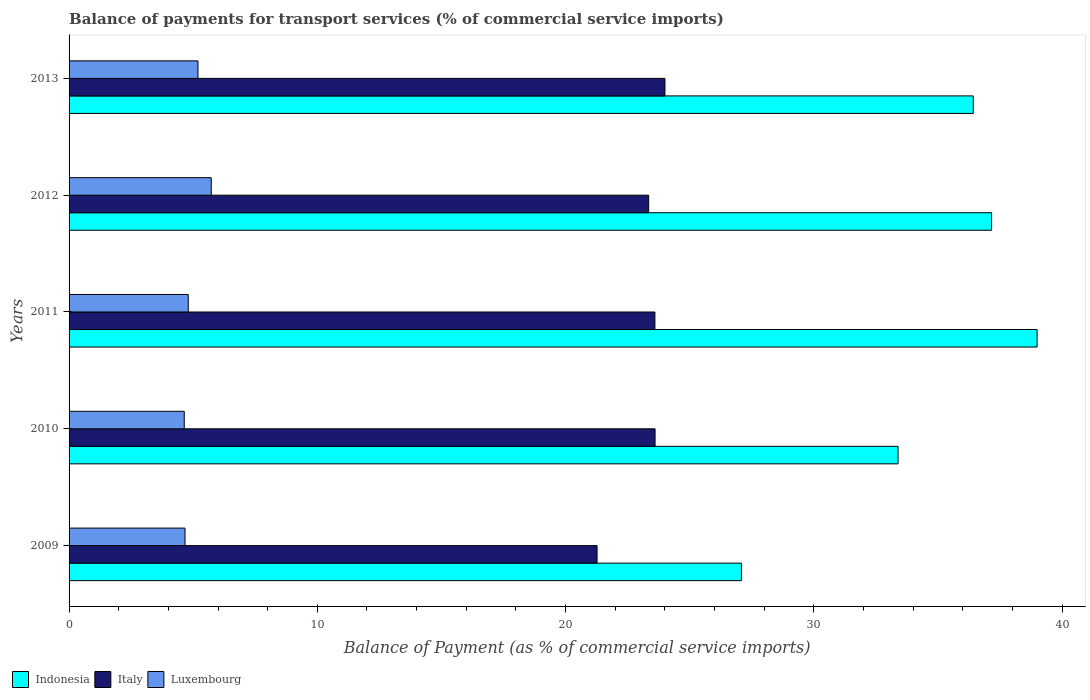How many different coloured bars are there?
Make the answer very short. 3. How many groups of bars are there?
Your answer should be very brief. 5. How many bars are there on the 2nd tick from the top?
Provide a succinct answer. 3. In how many cases, is the number of bars for a given year not equal to the number of legend labels?
Give a very brief answer. 0. What is the balance of payments for transport services in Indonesia in 2012?
Your response must be concise. 37.16. Across all years, what is the maximum balance of payments for transport services in Italy?
Provide a succinct answer. 24. Across all years, what is the minimum balance of payments for transport services in Indonesia?
Offer a terse response. 27.08. In which year was the balance of payments for transport services in Luxembourg maximum?
Give a very brief answer. 2012. In which year was the balance of payments for transport services in Indonesia minimum?
Offer a very short reply. 2009. What is the total balance of payments for transport services in Italy in the graph?
Keep it short and to the point. 115.82. What is the difference between the balance of payments for transport services in Indonesia in 2011 and that in 2012?
Provide a succinct answer. 1.83. What is the difference between the balance of payments for transport services in Indonesia in 2009 and the balance of payments for transport services in Luxembourg in 2013?
Offer a very short reply. 21.89. What is the average balance of payments for transport services in Indonesia per year?
Provide a short and direct response. 34.61. In the year 2011, what is the difference between the balance of payments for transport services in Indonesia and balance of payments for transport services in Luxembourg?
Give a very brief answer. 34.19. What is the ratio of the balance of payments for transport services in Luxembourg in 2010 to that in 2013?
Provide a short and direct response. 0.89. Is the balance of payments for transport services in Indonesia in 2010 less than that in 2013?
Provide a short and direct response. Yes. What is the difference between the highest and the second highest balance of payments for transport services in Luxembourg?
Offer a very short reply. 0.53. What is the difference between the highest and the lowest balance of payments for transport services in Italy?
Make the answer very short. 2.73. Is the sum of the balance of payments for transport services in Indonesia in 2009 and 2012 greater than the maximum balance of payments for transport services in Italy across all years?
Ensure brevity in your answer.  Yes. What does the 3rd bar from the bottom in 2011 represents?
Offer a very short reply. Luxembourg. Is it the case that in every year, the sum of the balance of payments for transport services in Luxembourg and balance of payments for transport services in Italy is greater than the balance of payments for transport services in Indonesia?
Provide a succinct answer. No. Are all the bars in the graph horizontal?
Ensure brevity in your answer.  Yes. Are the values on the major ticks of X-axis written in scientific E-notation?
Offer a terse response. No. Does the graph contain grids?
Ensure brevity in your answer.  No. How many legend labels are there?
Your answer should be compact. 3. What is the title of the graph?
Keep it short and to the point. Balance of payments for transport services (% of commercial service imports). Does "Middle East & North Africa (developing only)" appear as one of the legend labels in the graph?
Ensure brevity in your answer.  No. What is the label or title of the X-axis?
Give a very brief answer. Balance of Payment (as % of commercial service imports). What is the label or title of the Y-axis?
Make the answer very short. Years. What is the Balance of Payment (as % of commercial service imports) in Indonesia in 2009?
Ensure brevity in your answer.  27.08. What is the Balance of Payment (as % of commercial service imports) of Italy in 2009?
Keep it short and to the point. 21.27. What is the Balance of Payment (as % of commercial service imports) of Luxembourg in 2009?
Provide a succinct answer. 4.67. What is the Balance of Payment (as % of commercial service imports) in Indonesia in 2010?
Keep it short and to the point. 33.39. What is the Balance of Payment (as % of commercial service imports) in Italy in 2010?
Make the answer very short. 23.61. What is the Balance of Payment (as % of commercial service imports) of Luxembourg in 2010?
Give a very brief answer. 4.64. What is the Balance of Payment (as % of commercial service imports) in Indonesia in 2011?
Provide a short and direct response. 38.99. What is the Balance of Payment (as % of commercial service imports) in Italy in 2011?
Provide a short and direct response. 23.6. What is the Balance of Payment (as % of commercial service imports) of Luxembourg in 2011?
Give a very brief answer. 4.8. What is the Balance of Payment (as % of commercial service imports) of Indonesia in 2012?
Provide a short and direct response. 37.16. What is the Balance of Payment (as % of commercial service imports) of Italy in 2012?
Provide a succinct answer. 23.35. What is the Balance of Payment (as % of commercial service imports) in Luxembourg in 2012?
Offer a terse response. 5.73. What is the Balance of Payment (as % of commercial service imports) of Indonesia in 2013?
Your answer should be very brief. 36.42. What is the Balance of Payment (as % of commercial service imports) of Italy in 2013?
Your response must be concise. 24. What is the Balance of Payment (as % of commercial service imports) of Luxembourg in 2013?
Your response must be concise. 5.19. Across all years, what is the maximum Balance of Payment (as % of commercial service imports) of Indonesia?
Offer a very short reply. 38.99. Across all years, what is the maximum Balance of Payment (as % of commercial service imports) of Italy?
Your answer should be very brief. 24. Across all years, what is the maximum Balance of Payment (as % of commercial service imports) of Luxembourg?
Your response must be concise. 5.73. Across all years, what is the minimum Balance of Payment (as % of commercial service imports) of Indonesia?
Your response must be concise. 27.08. Across all years, what is the minimum Balance of Payment (as % of commercial service imports) of Italy?
Provide a succinct answer. 21.27. Across all years, what is the minimum Balance of Payment (as % of commercial service imports) in Luxembourg?
Offer a terse response. 4.64. What is the total Balance of Payment (as % of commercial service imports) of Indonesia in the graph?
Make the answer very short. 173.06. What is the total Balance of Payment (as % of commercial service imports) of Italy in the graph?
Give a very brief answer. 115.82. What is the total Balance of Payment (as % of commercial service imports) in Luxembourg in the graph?
Make the answer very short. 25.03. What is the difference between the Balance of Payment (as % of commercial service imports) of Indonesia in 2009 and that in 2010?
Keep it short and to the point. -6.31. What is the difference between the Balance of Payment (as % of commercial service imports) in Italy in 2009 and that in 2010?
Ensure brevity in your answer.  -2.34. What is the difference between the Balance of Payment (as % of commercial service imports) in Luxembourg in 2009 and that in 2010?
Your response must be concise. 0.03. What is the difference between the Balance of Payment (as % of commercial service imports) in Indonesia in 2009 and that in 2011?
Your answer should be compact. -11.91. What is the difference between the Balance of Payment (as % of commercial service imports) of Italy in 2009 and that in 2011?
Provide a succinct answer. -2.33. What is the difference between the Balance of Payment (as % of commercial service imports) in Luxembourg in 2009 and that in 2011?
Make the answer very short. -0.13. What is the difference between the Balance of Payment (as % of commercial service imports) in Indonesia in 2009 and that in 2012?
Keep it short and to the point. -10.08. What is the difference between the Balance of Payment (as % of commercial service imports) of Italy in 2009 and that in 2012?
Ensure brevity in your answer.  -2.08. What is the difference between the Balance of Payment (as % of commercial service imports) in Luxembourg in 2009 and that in 2012?
Your answer should be compact. -1.06. What is the difference between the Balance of Payment (as % of commercial service imports) in Indonesia in 2009 and that in 2013?
Ensure brevity in your answer.  -9.34. What is the difference between the Balance of Payment (as % of commercial service imports) in Italy in 2009 and that in 2013?
Offer a terse response. -2.73. What is the difference between the Balance of Payment (as % of commercial service imports) in Luxembourg in 2009 and that in 2013?
Offer a very short reply. -0.52. What is the difference between the Balance of Payment (as % of commercial service imports) in Indonesia in 2010 and that in 2011?
Give a very brief answer. -5.6. What is the difference between the Balance of Payment (as % of commercial service imports) in Italy in 2010 and that in 2011?
Make the answer very short. 0.01. What is the difference between the Balance of Payment (as % of commercial service imports) in Luxembourg in 2010 and that in 2011?
Give a very brief answer. -0.16. What is the difference between the Balance of Payment (as % of commercial service imports) in Indonesia in 2010 and that in 2012?
Provide a succinct answer. -3.77. What is the difference between the Balance of Payment (as % of commercial service imports) of Italy in 2010 and that in 2012?
Provide a short and direct response. 0.26. What is the difference between the Balance of Payment (as % of commercial service imports) in Luxembourg in 2010 and that in 2012?
Give a very brief answer. -1.09. What is the difference between the Balance of Payment (as % of commercial service imports) in Indonesia in 2010 and that in 2013?
Provide a short and direct response. -3.03. What is the difference between the Balance of Payment (as % of commercial service imports) of Italy in 2010 and that in 2013?
Give a very brief answer. -0.4. What is the difference between the Balance of Payment (as % of commercial service imports) in Luxembourg in 2010 and that in 2013?
Provide a short and direct response. -0.55. What is the difference between the Balance of Payment (as % of commercial service imports) in Indonesia in 2011 and that in 2012?
Provide a short and direct response. 1.83. What is the difference between the Balance of Payment (as % of commercial service imports) in Italy in 2011 and that in 2012?
Ensure brevity in your answer.  0.25. What is the difference between the Balance of Payment (as % of commercial service imports) in Luxembourg in 2011 and that in 2012?
Your answer should be very brief. -0.93. What is the difference between the Balance of Payment (as % of commercial service imports) in Indonesia in 2011 and that in 2013?
Provide a succinct answer. 2.57. What is the difference between the Balance of Payment (as % of commercial service imports) of Italy in 2011 and that in 2013?
Your response must be concise. -0.41. What is the difference between the Balance of Payment (as % of commercial service imports) in Luxembourg in 2011 and that in 2013?
Provide a short and direct response. -0.39. What is the difference between the Balance of Payment (as % of commercial service imports) in Indonesia in 2012 and that in 2013?
Provide a short and direct response. 0.74. What is the difference between the Balance of Payment (as % of commercial service imports) in Italy in 2012 and that in 2013?
Your answer should be very brief. -0.66. What is the difference between the Balance of Payment (as % of commercial service imports) of Luxembourg in 2012 and that in 2013?
Your answer should be compact. 0.53. What is the difference between the Balance of Payment (as % of commercial service imports) in Indonesia in 2009 and the Balance of Payment (as % of commercial service imports) in Italy in 2010?
Provide a short and direct response. 3.48. What is the difference between the Balance of Payment (as % of commercial service imports) of Indonesia in 2009 and the Balance of Payment (as % of commercial service imports) of Luxembourg in 2010?
Provide a succinct answer. 22.45. What is the difference between the Balance of Payment (as % of commercial service imports) in Italy in 2009 and the Balance of Payment (as % of commercial service imports) in Luxembourg in 2010?
Your response must be concise. 16.63. What is the difference between the Balance of Payment (as % of commercial service imports) of Indonesia in 2009 and the Balance of Payment (as % of commercial service imports) of Italy in 2011?
Your answer should be compact. 3.49. What is the difference between the Balance of Payment (as % of commercial service imports) of Indonesia in 2009 and the Balance of Payment (as % of commercial service imports) of Luxembourg in 2011?
Ensure brevity in your answer.  22.28. What is the difference between the Balance of Payment (as % of commercial service imports) in Italy in 2009 and the Balance of Payment (as % of commercial service imports) in Luxembourg in 2011?
Your response must be concise. 16.47. What is the difference between the Balance of Payment (as % of commercial service imports) of Indonesia in 2009 and the Balance of Payment (as % of commercial service imports) of Italy in 2012?
Ensure brevity in your answer.  3.74. What is the difference between the Balance of Payment (as % of commercial service imports) of Indonesia in 2009 and the Balance of Payment (as % of commercial service imports) of Luxembourg in 2012?
Offer a terse response. 21.36. What is the difference between the Balance of Payment (as % of commercial service imports) of Italy in 2009 and the Balance of Payment (as % of commercial service imports) of Luxembourg in 2012?
Ensure brevity in your answer.  15.54. What is the difference between the Balance of Payment (as % of commercial service imports) of Indonesia in 2009 and the Balance of Payment (as % of commercial service imports) of Italy in 2013?
Make the answer very short. 3.08. What is the difference between the Balance of Payment (as % of commercial service imports) of Indonesia in 2009 and the Balance of Payment (as % of commercial service imports) of Luxembourg in 2013?
Provide a short and direct response. 21.89. What is the difference between the Balance of Payment (as % of commercial service imports) in Italy in 2009 and the Balance of Payment (as % of commercial service imports) in Luxembourg in 2013?
Your answer should be compact. 16.08. What is the difference between the Balance of Payment (as % of commercial service imports) of Indonesia in 2010 and the Balance of Payment (as % of commercial service imports) of Italy in 2011?
Offer a very short reply. 9.8. What is the difference between the Balance of Payment (as % of commercial service imports) of Indonesia in 2010 and the Balance of Payment (as % of commercial service imports) of Luxembourg in 2011?
Give a very brief answer. 28.59. What is the difference between the Balance of Payment (as % of commercial service imports) of Italy in 2010 and the Balance of Payment (as % of commercial service imports) of Luxembourg in 2011?
Provide a short and direct response. 18.8. What is the difference between the Balance of Payment (as % of commercial service imports) of Indonesia in 2010 and the Balance of Payment (as % of commercial service imports) of Italy in 2012?
Ensure brevity in your answer.  10.05. What is the difference between the Balance of Payment (as % of commercial service imports) of Indonesia in 2010 and the Balance of Payment (as % of commercial service imports) of Luxembourg in 2012?
Give a very brief answer. 27.67. What is the difference between the Balance of Payment (as % of commercial service imports) in Italy in 2010 and the Balance of Payment (as % of commercial service imports) in Luxembourg in 2012?
Your answer should be compact. 17.88. What is the difference between the Balance of Payment (as % of commercial service imports) in Indonesia in 2010 and the Balance of Payment (as % of commercial service imports) in Italy in 2013?
Give a very brief answer. 9.39. What is the difference between the Balance of Payment (as % of commercial service imports) in Indonesia in 2010 and the Balance of Payment (as % of commercial service imports) in Luxembourg in 2013?
Your response must be concise. 28.2. What is the difference between the Balance of Payment (as % of commercial service imports) in Italy in 2010 and the Balance of Payment (as % of commercial service imports) in Luxembourg in 2013?
Provide a succinct answer. 18.41. What is the difference between the Balance of Payment (as % of commercial service imports) in Indonesia in 2011 and the Balance of Payment (as % of commercial service imports) in Italy in 2012?
Ensure brevity in your answer.  15.65. What is the difference between the Balance of Payment (as % of commercial service imports) in Indonesia in 2011 and the Balance of Payment (as % of commercial service imports) in Luxembourg in 2012?
Make the answer very short. 33.27. What is the difference between the Balance of Payment (as % of commercial service imports) of Italy in 2011 and the Balance of Payment (as % of commercial service imports) of Luxembourg in 2012?
Ensure brevity in your answer.  17.87. What is the difference between the Balance of Payment (as % of commercial service imports) in Indonesia in 2011 and the Balance of Payment (as % of commercial service imports) in Italy in 2013?
Offer a terse response. 14.99. What is the difference between the Balance of Payment (as % of commercial service imports) of Indonesia in 2011 and the Balance of Payment (as % of commercial service imports) of Luxembourg in 2013?
Offer a terse response. 33.8. What is the difference between the Balance of Payment (as % of commercial service imports) in Italy in 2011 and the Balance of Payment (as % of commercial service imports) in Luxembourg in 2013?
Provide a succinct answer. 18.41. What is the difference between the Balance of Payment (as % of commercial service imports) of Indonesia in 2012 and the Balance of Payment (as % of commercial service imports) of Italy in 2013?
Offer a very short reply. 13.16. What is the difference between the Balance of Payment (as % of commercial service imports) of Indonesia in 2012 and the Balance of Payment (as % of commercial service imports) of Luxembourg in 2013?
Provide a succinct answer. 31.97. What is the difference between the Balance of Payment (as % of commercial service imports) in Italy in 2012 and the Balance of Payment (as % of commercial service imports) in Luxembourg in 2013?
Ensure brevity in your answer.  18.15. What is the average Balance of Payment (as % of commercial service imports) in Indonesia per year?
Your response must be concise. 34.61. What is the average Balance of Payment (as % of commercial service imports) in Italy per year?
Keep it short and to the point. 23.16. What is the average Balance of Payment (as % of commercial service imports) of Luxembourg per year?
Offer a very short reply. 5.01. In the year 2009, what is the difference between the Balance of Payment (as % of commercial service imports) of Indonesia and Balance of Payment (as % of commercial service imports) of Italy?
Provide a succinct answer. 5.82. In the year 2009, what is the difference between the Balance of Payment (as % of commercial service imports) of Indonesia and Balance of Payment (as % of commercial service imports) of Luxembourg?
Give a very brief answer. 22.41. In the year 2009, what is the difference between the Balance of Payment (as % of commercial service imports) of Italy and Balance of Payment (as % of commercial service imports) of Luxembourg?
Offer a very short reply. 16.6. In the year 2010, what is the difference between the Balance of Payment (as % of commercial service imports) of Indonesia and Balance of Payment (as % of commercial service imports) of Italy?
Give a very brief answer. 9.79. In the year 2010, what is the difference between the Balance of Payment (as % of commercial service imports) in Indonesia and Balance of Payment (as % of commercial service imports) in Luxembourg?
Offer a very short reply. 28.75. In the year 2010, what is the difference between the Balance of Payment (as % of commercial service imports) of Italy and Balance of Payment (as % of commercial service imports) of Luxembourg?
Offer a terse response. 18.97. In the year 2011, what is the difference between the Balance of Payment (as % of commercial service imports) of Indonesia and Balance of Payment (as % of commercial service imports) of Italy?
Offer a very short reply. 15.4. In the year 2011, what is the difference between the Balance of Payment (as % of commercial service imports) in Indonesia and Balance of Payment (as % of commercial service imports) in Luxembourg?
Offer a terse response. 34.19. In the year 2011, what is the difference between the Balance of Payment (as % of commercial service imports) in Italy and Balance of Payment (as % of commercial service imports) in Luxembourg?
Offer a terse response. 18.8. In the year 2012, what is the difference between the Balance of Payment (as % of commercial service imports) in Indonesia and Balance of Payment (as % of commercial service imports) in Italy?
Keep it short and to the point. 13.81. In the year 2012, what is the difference between the Balance of Payment (as % of commercial service imports) of Indonesia and Balance of Payment (as % of commercial service imports) of Luxembourg?
Keep it short and to the point. 31.43. In the year 2012, what is the difference between the Balance of Payment (as % of commercial service imports) of Italy and Balance of Payment (as % of commercial service imports) of Luxembourg?
Make the answer very short. 17.62. In the year 2013, what is the difference between the Balance of Payment (as % of commercial service imports) in Indonesia and Balance of Payment (as % of commercial service imports) in Italy?
Ensure brevity in your answer.  12.42. In the year 2013, what is the difference between the Balance of Payment (as % of commercial service imports) in Indonesia and Balance of Payment (as % of commercial service imports) in Luxembourg?
Make the answer very short. 31.23. In the year 2013, what is the difference between the Balance of Payment (as % of commercial service imports) in Italy and Balance of Payment (as % of commercial service imports) in Luxembourg?
Offer a very short reply. 18.81. What is the ratio of the Balance of Payment (as % of commercial service imports) of Indonesia in 2009 to that in 2010?
Ensure brevity in your answer.  0.81. What is the ratio of the Balance of Payment (as % of commercial service imports) in Italy in 2009 to that in 2010?
Ensure brevity in your answer.  0.9. What is the ratio of the Balance of Payment (as % of commercial service imports) of Luxembourg in 2009 to that in 2010?
Give a very brief answer. 1.01. What is the ratio of the Balance of Payment (as % of commercial service imports) of Indonesia in 2009 to that in 2011?
Give a very brief answer. 0.69. What is the ratio of the Balance of Payment (as % of commercial service imports) of Italy in 2009 to that in 2011?
Your response must be concise. 0.9. What is the ratio of the Balance of Payment (as % of commercial service imports) of Luxembourg in 2009 to that in 2011?
Your response must be concise. 0.97. What is the ratio of the Balance of Payment (as % of commercial service imports) in Indonesia in 2009 to that in 2012?
Offer a very short reply. 0.73. What is the ratio of the Balance of Payment (as % of commercial service imports) in Italy in 2009 to that in 2012?
Make the answer very short. 0.91. What is the ratio of the Balance of Payment (as % of commercial service imports) in Luxembourg in 2009 to that in 2012?
Offer a very short reply. 0.82. What is the ratio of the Balance of Payment (as % of commercial service imports) of Indonesia in 2009 to that in 2013?
Your response must be concise. 0.74. What is the ratio of the Balance of Payment (as % of commercial service imports) in Italy in 2009 to that in 2013?
Give a very brief answer. 0.89. What is the ratio of the Balance of Payment (as % of commercial service imports) of Luxembourg in 2009 to that in 2013?
Provide a short and direct response. 0.9. What is the ratio of the Balance of Payment (as % of commercial service imports) of Indonesia in 2010 to that in 2011?
Give a very brief answer. 0.86. What is the ratio of the Balance of Payment (as % of commercial service imports) of Luxembourg in 2010 to that in 2011?
Provide a short and direct response. 0.97. What is the ratio of the Balance of Payment (as % of commercial service imports) in Indonesia in 2010 to that in 2012?
Give a very brief answer. 0.9. What is the ratio of the Balance of Payment (as % of commercial service imports) of Italy in 2010 to that in 2012?
Make the answer very short. 1.01. What is the ratio of the Balance of Payment (as % of commercial service imports) of Luxembourg in 2010 to that in 2012?
Provide a short and direct response. 0.81. What is the ratio of the Balance of Payment (as % of commercial service imports) of Indonesia in 2010 to that in 2013?
Your answer should be compact. 0.92. What is the ratio of the Balance of Payment (as % of commercial service imports) of Italy in 2010 to that in 2013?
Keep it short and to the point. 0.98. What is the ratio of the Balance of Payment (as % of commercial service imports) in Luxembourg in 2010 to that in 2013?
Make the answer very short. 0.89. What is the ratio of the Balance of Payment (as % of commercial service imports) of Indonesia in 2011 to that in 2012?
Offer a very short reply. 1.05. What is the ratio of the Balance of Payment (as % of commercial service imports) of Italy in 2011 to that in 2012?
Make the answer very short. 1.01. What is the ratio of the Balance of Payment (as % of commercial service imports) in Luxembourg in 2011 to that in 2012?
Offer a terse response. 0.84. What is the ratio of the Balance of Payment (as % of commercial service imports) in Indonesia in 2011 to that in 2013?
Offer a very short reply. 1.07. What is the ratio of the Balance of Payment (as % of commercial service imports) in Italy in 2011 to that in 2013?
Make the answer very short. 0.98. What is the ratio of the Balance of Payment (as % of commercial service imports) in Luxembourg in 2011 to that in 2013?
Your response must be concise. 0.92. What is the ratio of the Balance of Payment (as % of commercial service imports) of Indonesia in 2012 to that in 2013?
Provide a short and direct response. 1.02. What is the ratio of the Balance of Payment (as % of commercial service imports) in Italy in 2012 to that in 2013?
Your response must be concise. 0.97. What is the ratio of the Balance of Payment (as % of commercial service imports) in Luxembourg in 2012 to that in 2013?
Provide a short and direct response. 1.1. What is the difference between the highest and the second highest Balance of Payment (as % of commercial service imports) of Indonesia?
Keep it short and to the point. 1.83. What is the difference between the highest and the second highest Balance of Payment (as % of commercial service imports) in Italy?
Your response must be concise. 0.4. What is the difference between the highest and the second highest Balance of Payment (as % of commercial service imports) of Luxembourg?
Make the answer very short. 0.53. What is the difference between the highest and the lowest Balance of Payment (as % of commercial service imports) in Indonesia?
Offer a very short reply. 11.91. What is the difference between the highest and the lowest Balance of Payment (as % of commercial service imports) in Italy?
Offer a terse response. 2.73. What is the difference between the highest and the lowest Balance of Payment (as % of commercial service imports) of Luxembourg?
Your answer should be very brief. 1.09. 